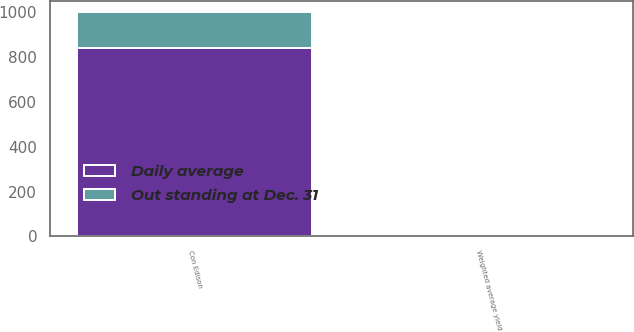Convert chart. <chart><loc_0><loc_0><loc_500><loc_500><stacked_bar_chart><ecel><fcel>Con Edison<fcel>Weighted average yield<nl><fcel>Daily average<fcel>840<fcel>5.5<nl><fcel>Out standing at Dec. 31<fcel>160<fcel>5.3<nl></chart> 